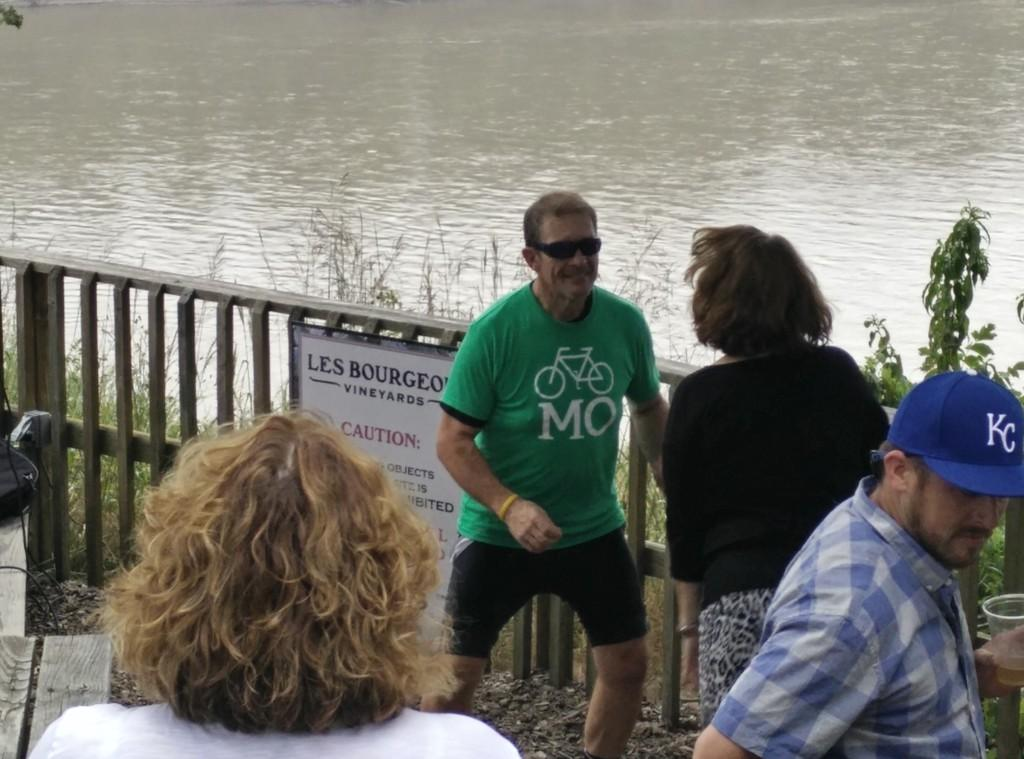What are the people in the image doing? The people in the image are standing and talking. What can be seen in the background of the image? There is fencing visible in the image. What is the water flow in the image? The water flow in the image is not specified, but it is mentioned that there is water flow present. What type of camp can be seen in the image? There is no camp present in the image; it features people standing and talking with fencing visible in the background. 